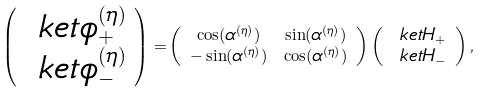Convert formula to latex. <formula><loc_0><loc_0><loc_500><loc_500>\left ( \begin{array} { c } \ k e t { \phi _ { + } ^ { ( \eta ) } } \\ \ k e t { \phi _ { - } ^ { ( \eta ) } } \end{array} \right ) = & \left ( \begin{array} { c c } \cos ( \alpha ^ { ( \eta ) } ) & \sin ( \alpha ^ { ( \eta ) } ) \\ - \sin ( \alpha ^ { ( \eta ) } ) & \cos ( \alpha ^ { ( \eta ) } ) \end{array} \right ) \left ( \begin{array} { c } \ k e t { H _ { + } } \\ \ k e t { H _ { - } } \end{array} \right ) ,</formula> 